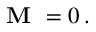<formula> <loc_0><loc_0><loc_500><loc_500>{ M } = 0 \, .</formula> 